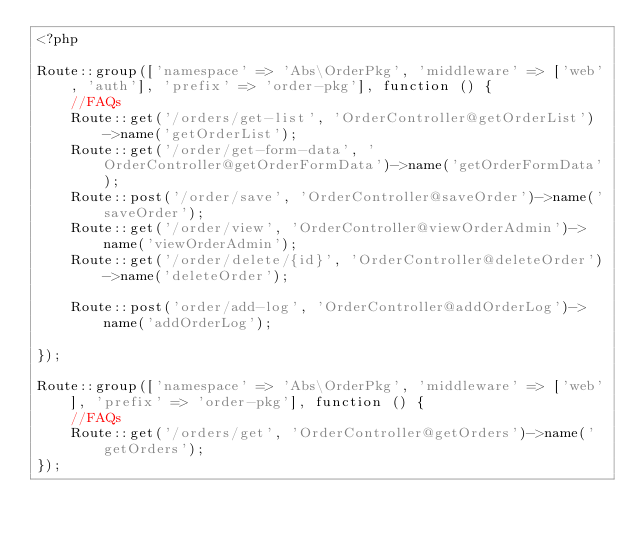<code> <loc_0><loc_0><loc_500><loc_500><_PHP_><?php

Route::group(['namespace' => 'Abs\OrderPkg', 'middleware' => ['web', 'auth'], 'prefix' => 'order-pkg'], function () {
	//FAQs
	Route::get('/orders/get-list', 'OrderController@getOrderList')->name('getOrderList');
	Route::get('/order/get-form-data', 'OrderController@getOrderFormData')->name('getOrderFormData');
	Route::post('/order/save', 'OrderController@saveOrder')->name('saveOrder');
	Route::get('/order/view', 'OrderController@viewOrderAdmin')->name('viewOrderAdmin');
	Route::get('/order/delete/{id}', 'OrderController@deleteOrder')->name('deleteOrder');

	Route::post('order/add-log', 'OrderController@addOrderLog')->name('addOrderLog');

});

Route::group(['namespace' => 'Abs\OrderPkg', 'middleware' => ['web'], 'prefix' => 'order-pkg'], function () {
	//FAQs
	Route::get('/orders/get', 'OrderController@getOrders')->name('getOrders');
});
</code> 